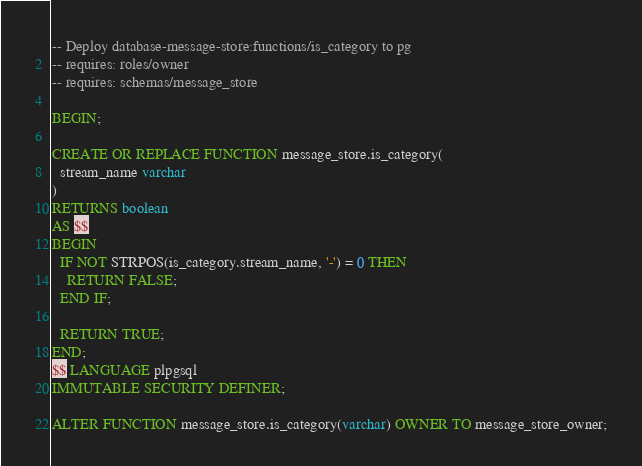Convert code to text. <code><loc_0><loc_0><loc_500><loc_500><_SQL_>-- Deploy database-message-store:functions/is_category to pg
-- requires: roles/owner
-- requires: schemas/message_store

BEGIN;

CREATE OR REPLACE FUNCTION message_store.is_category(
  stream_name varchar
)
RETURNS boolean
AS $$
BEGIN
  IF NOT STRPOS(is_category.stream_name, '-') = 0 THEN
    RETURN FALSE;
  END IF;

  RETURN TRUE;
END;
$$ LANGUAGE plpgsql
IMMUTABLE SECURITY DEFINER;

ALTER FUNCTION message_store.is_category(varchar) OWNER TO message_store_owner;
</code> 